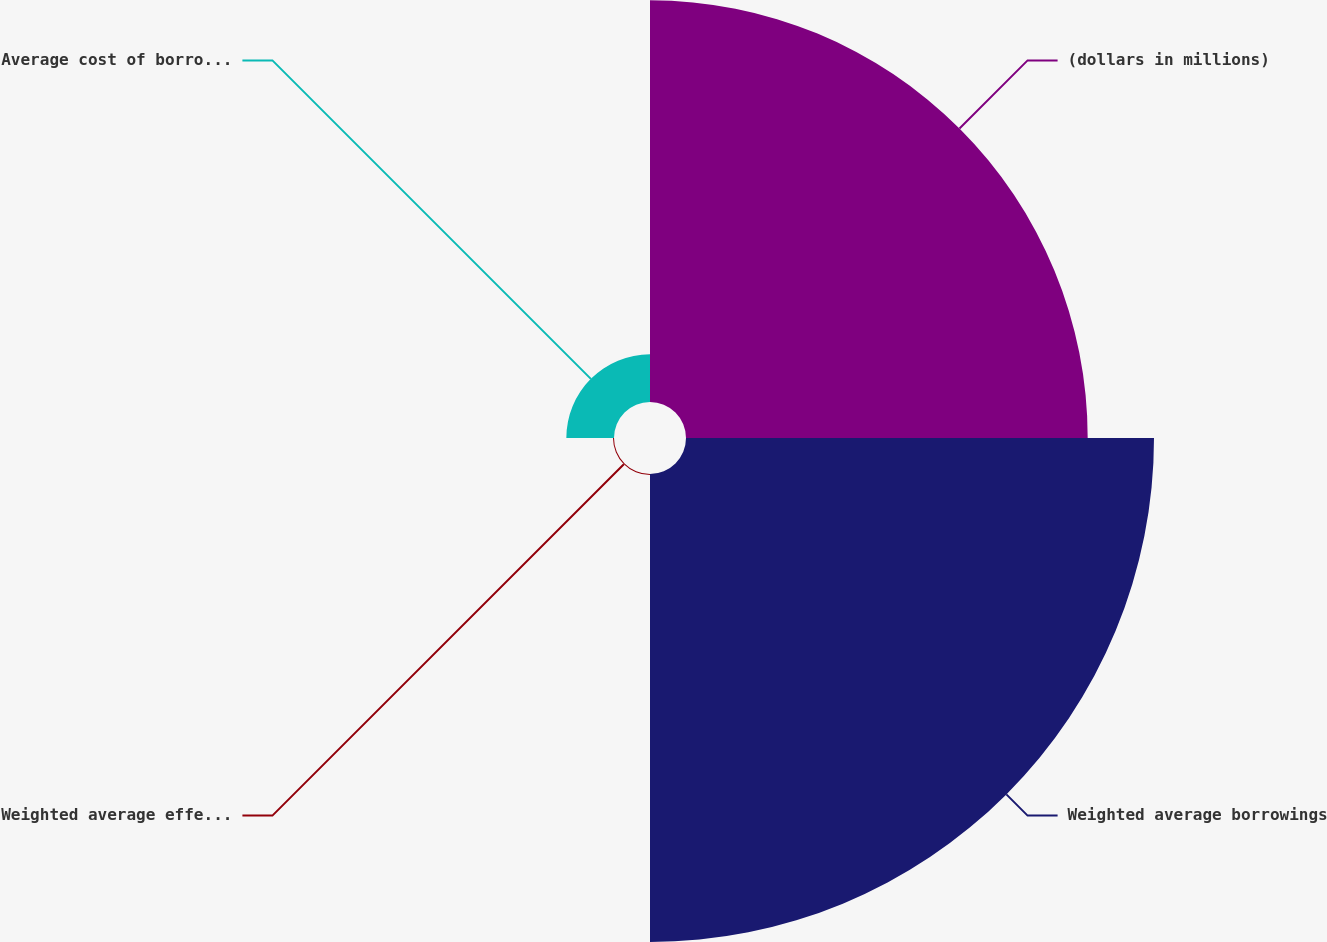Convert chart. <chart><loc_0><loc_0><loc_500><loc_500><pie_chart><fcel>(dollars in millions)<fcel>Weighted average borrowings<fcel>Weighted average effective<fcel>Average cost of borrowing (1)<nl><fcel>43.74%<fcel>50.96%<fcel>0.11%<fcel>5.19%<nl></chart> 